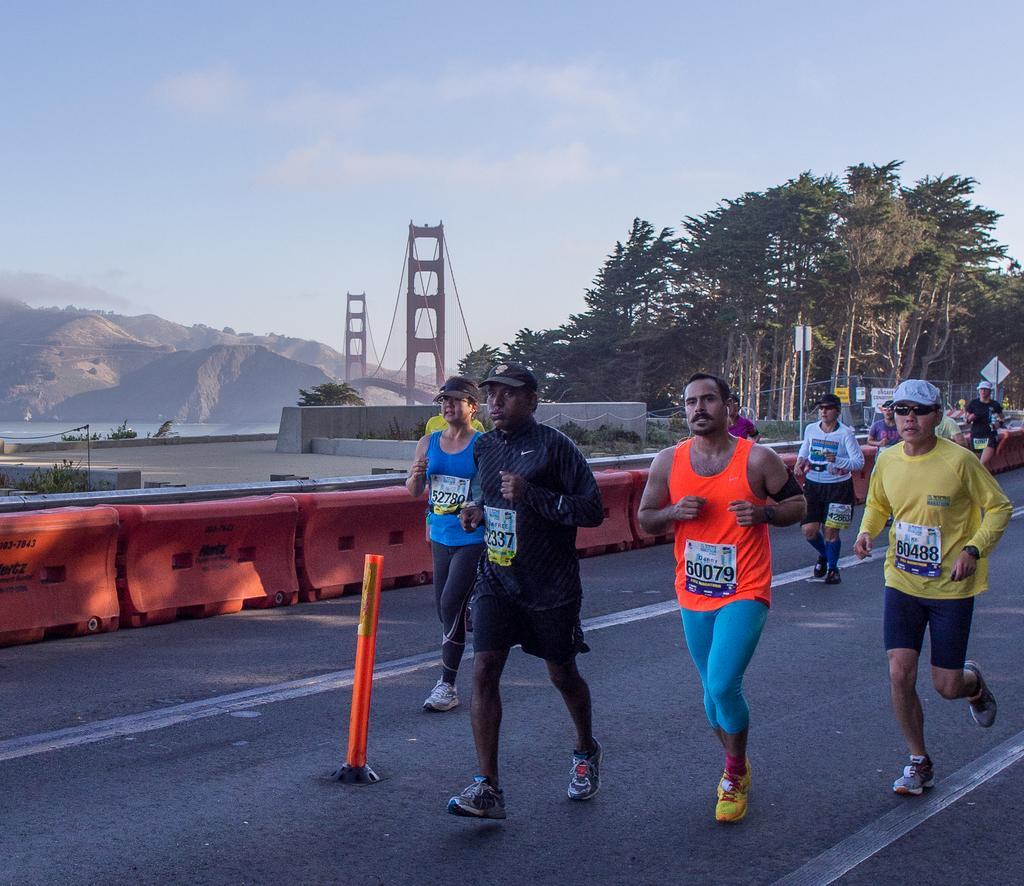Describe this image in one or two sentences. In the center of the image there are people running on the road. In the background of the image there are mountains. There is a bridge. There are trees. There are sign boards. In the center of the image there are barriers. There is a safety pole at the center of the road. At the top of the image there is sky. 